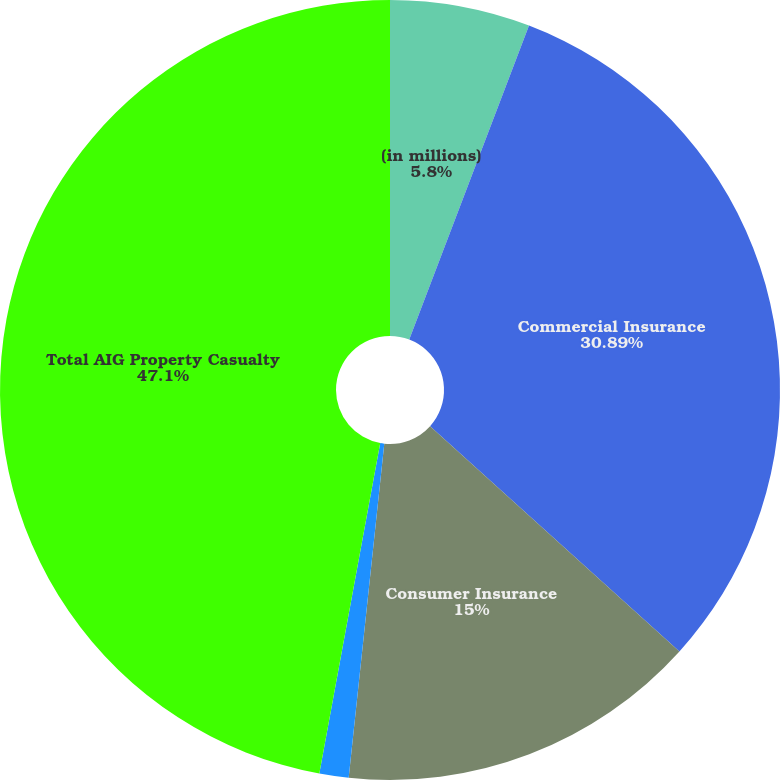Convert chart. <chart><loc_0><loc_0><loc_500><loc_500><pie_chart><fcel>(in millions)<fcel>Commercial Insurance<fcel>Consumer Insurance<fcel>Other<fcel>Total AIG Property Casualty<nl><fcel>5.8%<fcel>30.89%<fcel>15.0%<fcel>1.21%<fcel>47.1%<nl></chart> 